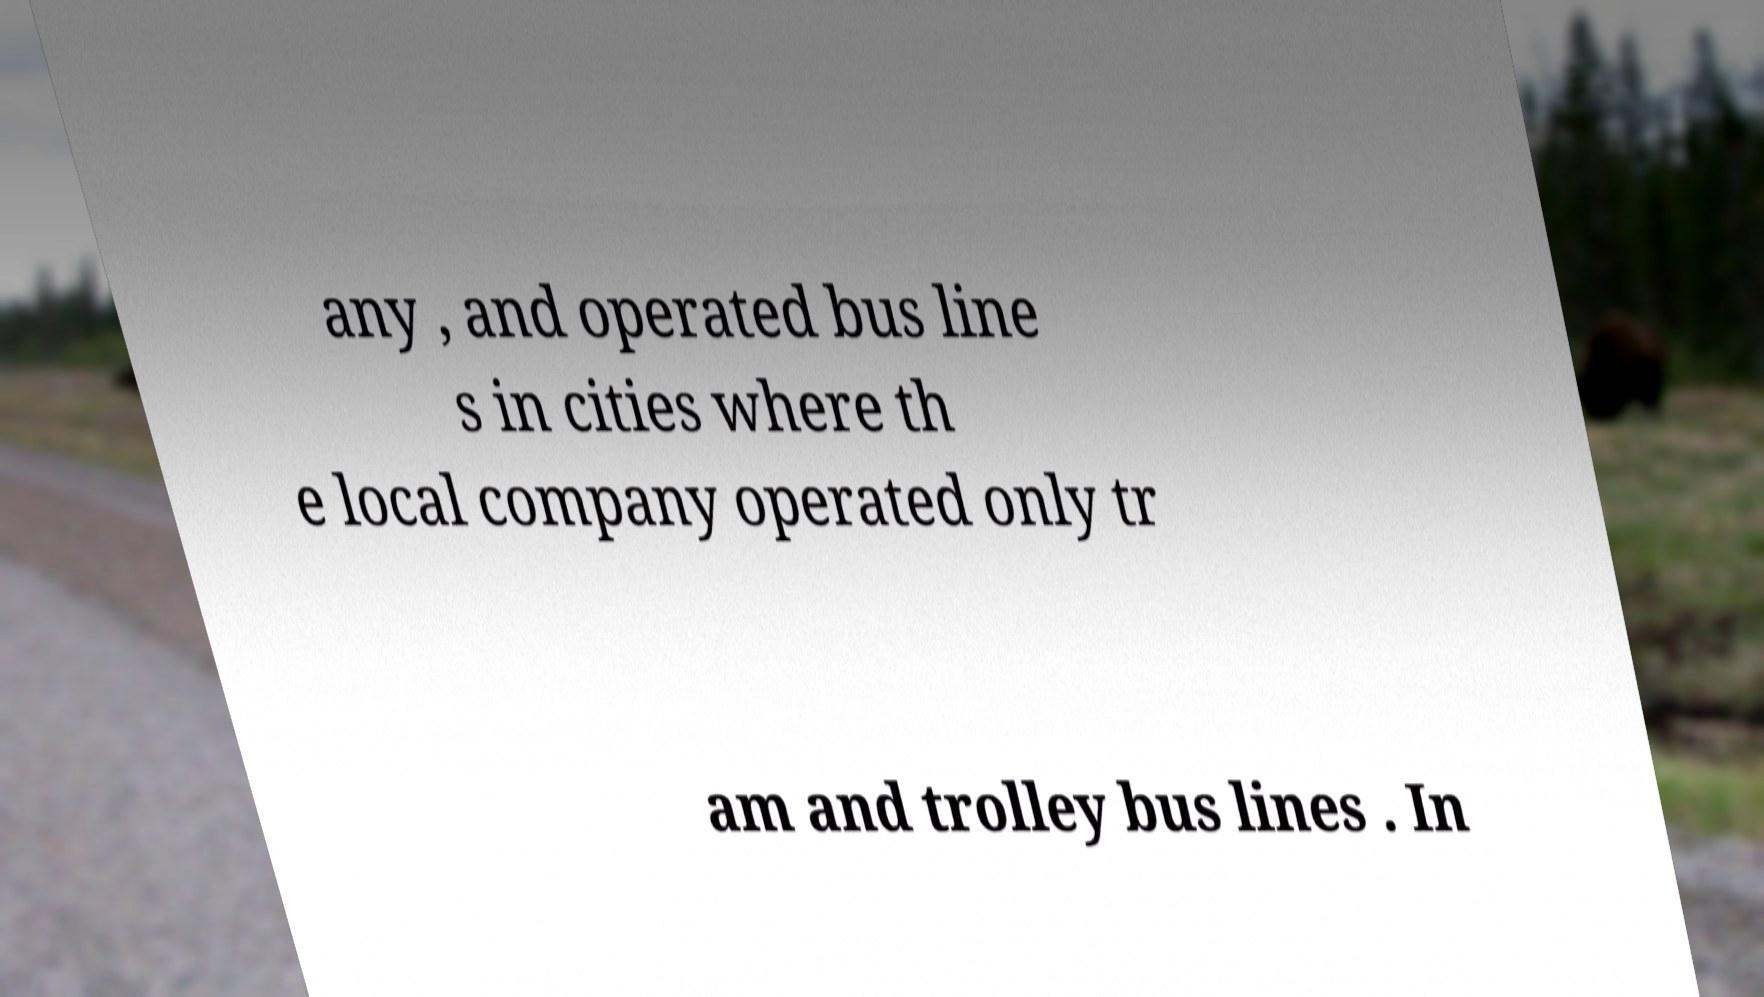What messages or text are displayed in this image? I need them in a readable, typed format. any , and operated bus line s in cities where th e local company operated only tr am and trolley bus lines . In 